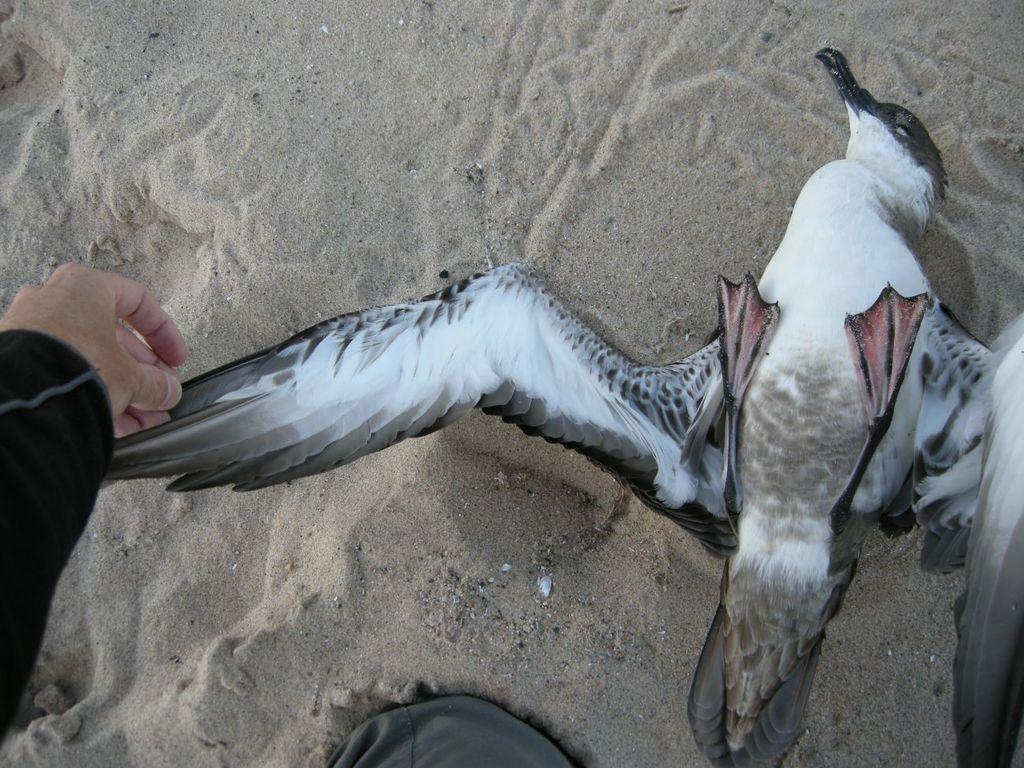What type of animal is present in the image? There is a bird in the image. Where is the bird located? The bird is on the sand. Can you see any human presence in the image? Yes, there is a hand of a person visible in the image. What type of stamp can be seen on the bird's wing in the image? There is no stamp present on the bird's wing in the image. Is the bird connected to a chain in the image? There is no chain present in the image. 